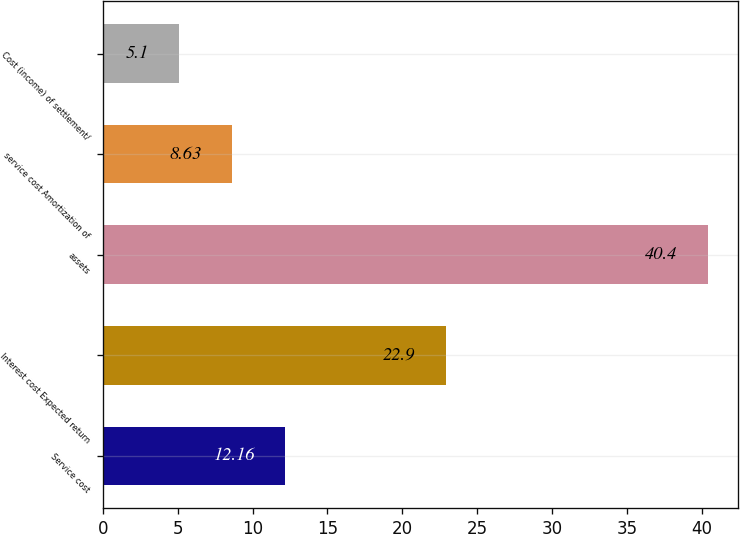<chart> <loc_0><loc_0><loc_500><loc_500><bar_chart><fcel>Service cost<fcel>Interest cost Expected return<fcel>assets<fcel>service cost Amortization of<fcel>Cost (income) of settlement/<nl><fcel>12.16<fcel>22.9<fcel>40.4<fcel>8.63<fcel>5.1<nl></chart> 